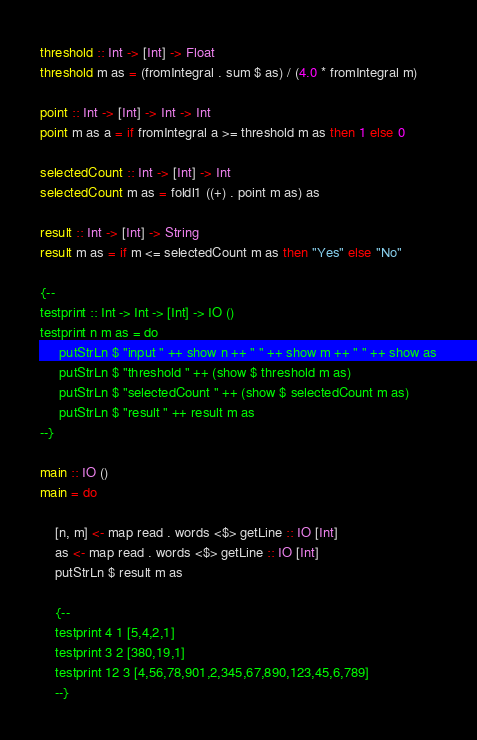<code> <loc_0><loc_0><loc_500><loc_500><_Haskell_>threshold :: Int -> [Int] -> Float
threshold m as = (fromIntegral . sum $ as) / (4.0 * fromIntegral m) 

point :: Int -> [Int] -> Int -> Int
point m as a = if fromIntegral a >= threshold m as then 1 else 0

selectedCount :: Int -> [Int] -> Int
selectedCount m as = foldl1 ((+) . point m as) as

result :: Int -> [Int] -> String
result m as = if m <= selectedCount m as then "Yes" else "No"

{--
testprint :: Int -> Int -> [Int] -> IO ()
testprint n m as = do
     putStrLn $ "input " ++ show n ++ " " ++ show m ++ " " ++ show as
     putStrLn $ "threshold " ++ (show $ threshold m as) 
     putStrLn $ "selectedCount " ++ (show $ selectedCount m as)
     putStrLn $ "result " ++ result m as
--}

main :: IO ()
main = do

    [n, m] <- map read . words <$> getLine :: IO [Int]
    as <- map read . words <$> getLine :: IO [Int]
    putStrLn $ result m as
    
    {--
    testprint 4 1 [5,4,2,1]
    testprint 3 2 [380,19,1]
    testprint 12 3 [4,56,78,901,2,345,67,890,123,45,6,789]
    --}
</code> 